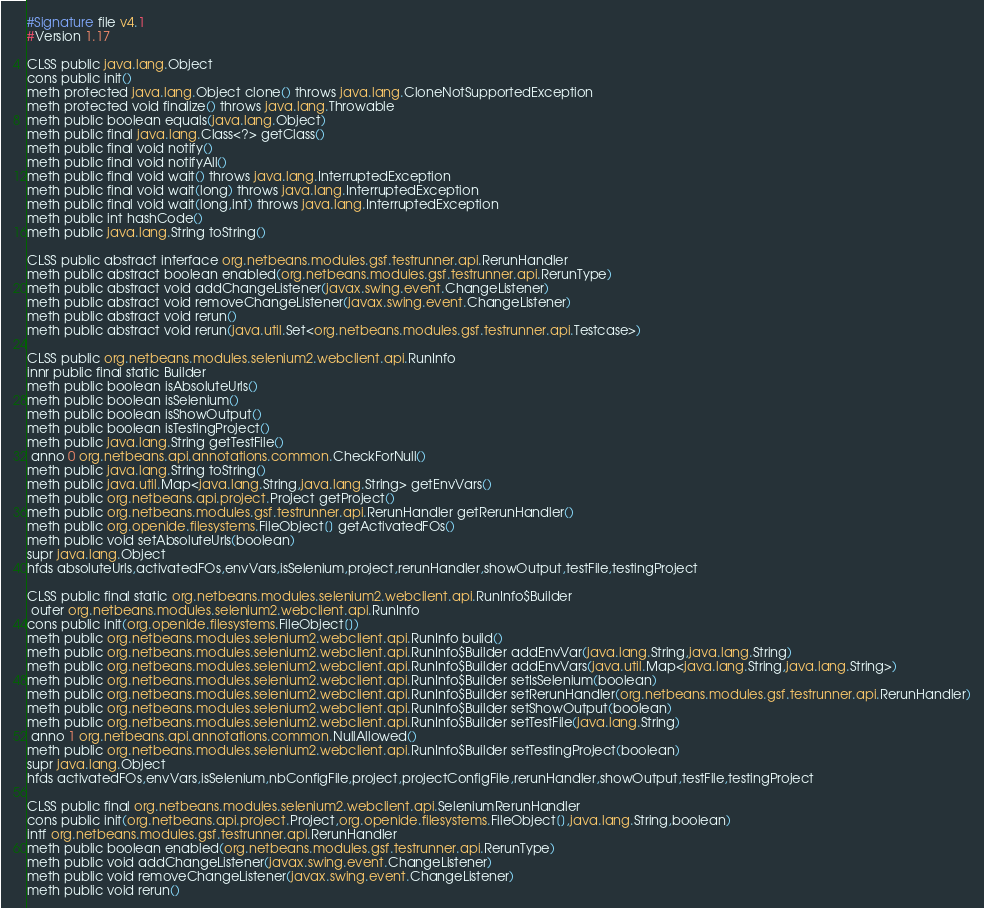Convert code to text. <code><loc_0><loc_0><loc_500><loc_500><_SML_>#Signature file v4.1
#Version 1.17

CLSS public java.lang.Object
cons public init()
meth protected java.lang.Object clone() throws java.lang.CloneNotSupportedException
meth protected void finalize() throws java.lang.Throwable
meth public boolean equals(java.lang.Object)
meth public final java.lang.Class<?> getClass()
meth public final void notify()
meth public final void notifyAll()
meth public final void wait() throws java.lang.InterruptedException
meth public final void wait(long) throws java.lang.InterruptedException
meth public final void wait(long,int) throws java.lang.InterruptedException
meth public int hashCode()
meth public java.lang.String toString()

CLSS public abstract interface org.netbeans.modules.gsf.testrunner.api.RerunHandler
meth public abstract boolean enabled(org.netbeans.modules.gsf.testrunner.api.RerunType)
meth public abstract void addChangeListener(javax.swing.event.ChangeListener)
meth public abstract void removeChangeListener(javax.swing.event.ChangeListener)
meth public abstract void rerun()
meth public abstract void rerun(java.util.Set<org.netbeans.modules.gsf.testrunner.api.Testcase>)

CLSS public org.netbeans.modules.selenium2.webclient.api.RunInfo
innr public final static Builder
meth public boolean isAbsoluteUrls()
meth public boolean isSelenium()
meth public boolean isShowOutput()
meth public boolean isTestingProject()
meth public java.lang.String getTestFile()
 anno 0 org.netbeans.api.annotations.common.CheckForNull()
meth public java.lang.String toString()
meth public java.util.Map<java.lang.String,java.lang.String> getEnvVars()
meth public org.netbeans.api.project.Project getProject()
meth public org.netbeans.modules.gsf.testrunner.api.RerunHandler getRerunHandler()
meth public org.openide.filesystems.FileObject[] getActivatedFOs()
meth public void setAbsoluteUrls(boolean)
supr java.lang.Object
hfds absoluteUrls,activatedFOs,envVars,isSelenium,project,rerunHandler,showOutput,testFile,testingProject

CLSS public final static org.netbeans.modules.selenium2.webclient.api.RunInfo$Builder
 outer org.netbeans.modules.selenium2.webclient.api.RunInfo
cons public init(org.openide.filesystems.FileObject[])
meth public org.netbeans.modules.selenium2.webclient.api.RunInfo build()
meth public org.netbeans.modules.selenium2.webclient.api.RunInfo$Builder addEnvVar(java.lang.String,java.lang.String)
meth public org.netbeans.modules.selenium2.webclient.api.RunInfo$Builder addEnvVars(java.util.Map<java.lang.String,java.lang.String>)
meth public org.netbeans.modules.selenium2.webclient.api.RunInfo$Builder setIsSelenium(boolean)
meth public org.netbeans.modules.selenium2.webclient.api.RunInfo$Builder setRerunHandler(org.netbeans.modules.gsf.testrunner.api.RerunHandler)
meth public org.netbeans.modules.selenium2.webclient.api.RunInfo$Builder setShowOutput(boolean)
meth public org.netbeans.modules.selenium2.webclient.api.RunInfo$Builder setTestFile(java.lang.String)
 anno 1 org.netbeans.api.annotations.common.NullAllowed()
meth public org.netbeans.modules.selenium2.webclient.api.RunInfo$Builder setTestingProject(boolean)
supr java.lang.Object
hfds activatedFOs,envVars,isSelenium,nbConfigFile,project,projectConfigFile,rerunHandler,showOutput,testFile,testingProject

CLSS public final org.netbeans.modules.selenium2.webclient.api.SeleniumRerunHandler
cons public init(org.netbeans.api.project.Project,org.openide.filesystems.FileObject[],java.lang.String,boolean)
intf org.netbeans.modules.gsf.testrunner.api.RerunHandler
meth public boolean enabled(org.netbeans.modules.gsf.testrunner.api.RerunType)
meth public void addChangeListener(javax.swing.event.ChangeListener)
meth public void removeChangeListener(javax.swing.event.ChangeListener)
meth public void rerun()</code> 